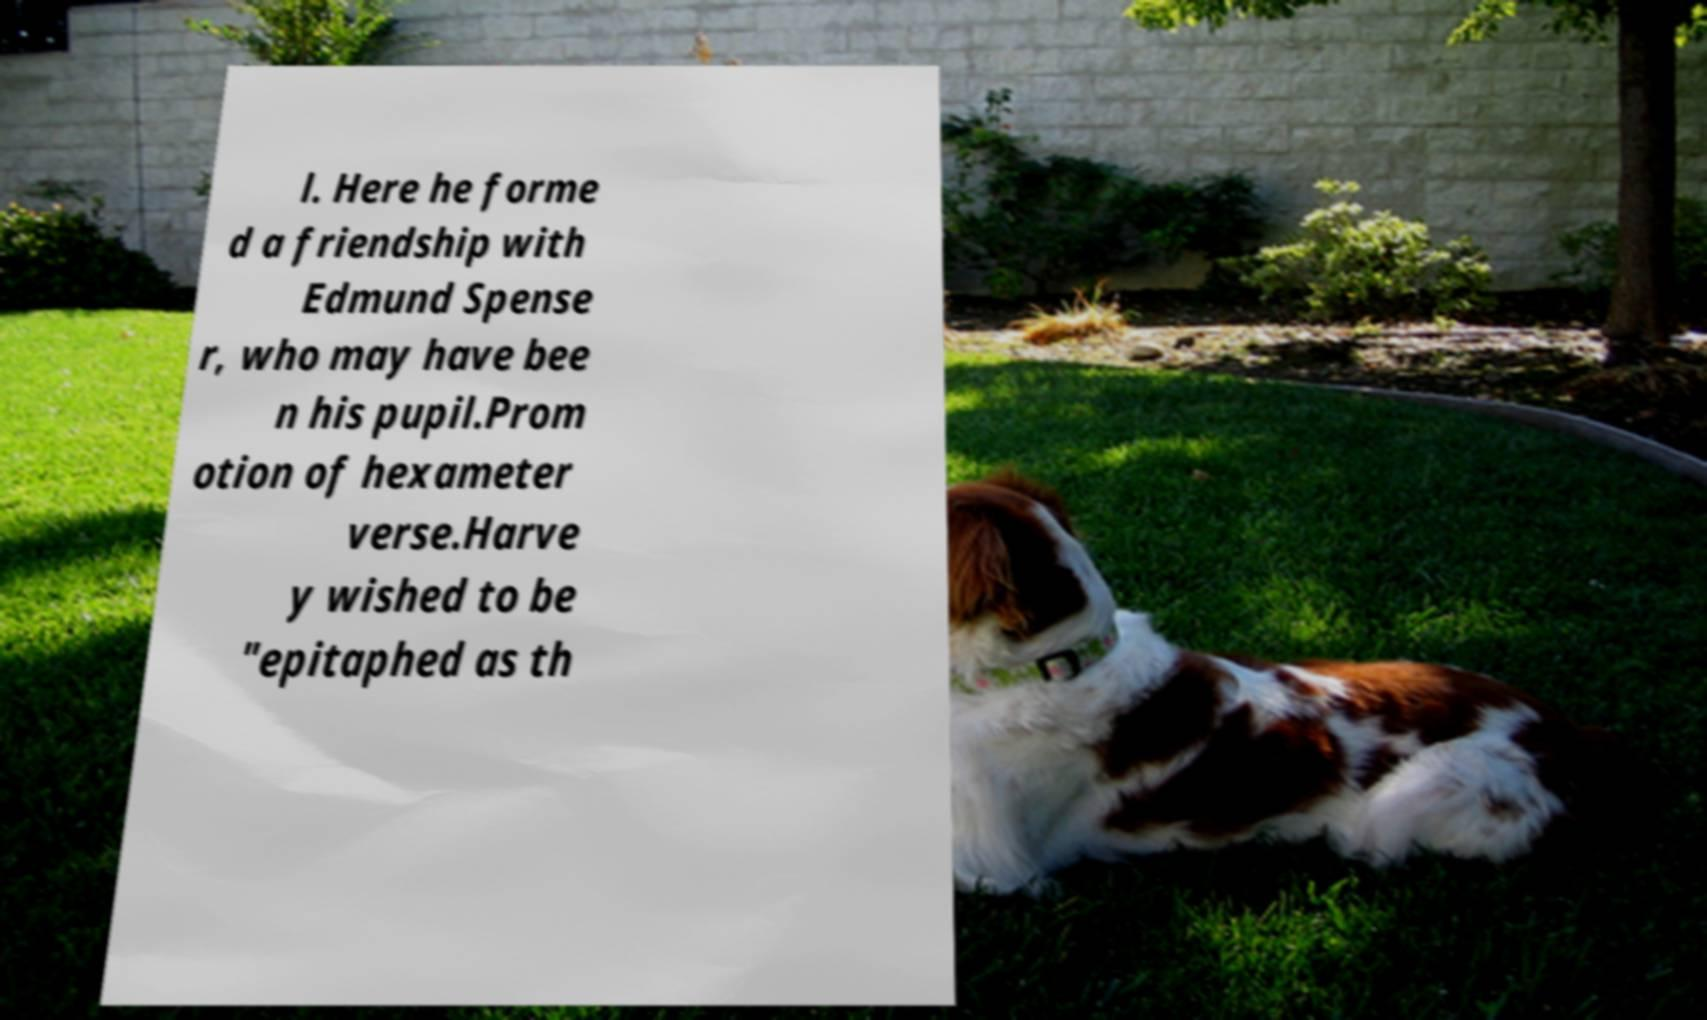Could you extract and type out the text from this image? l. Here he forme d a friendship with Edmund Spense r, who may have bee n his pupil.Prom otion of hexameter verse.Harve y wished to be "epitaphed as th 